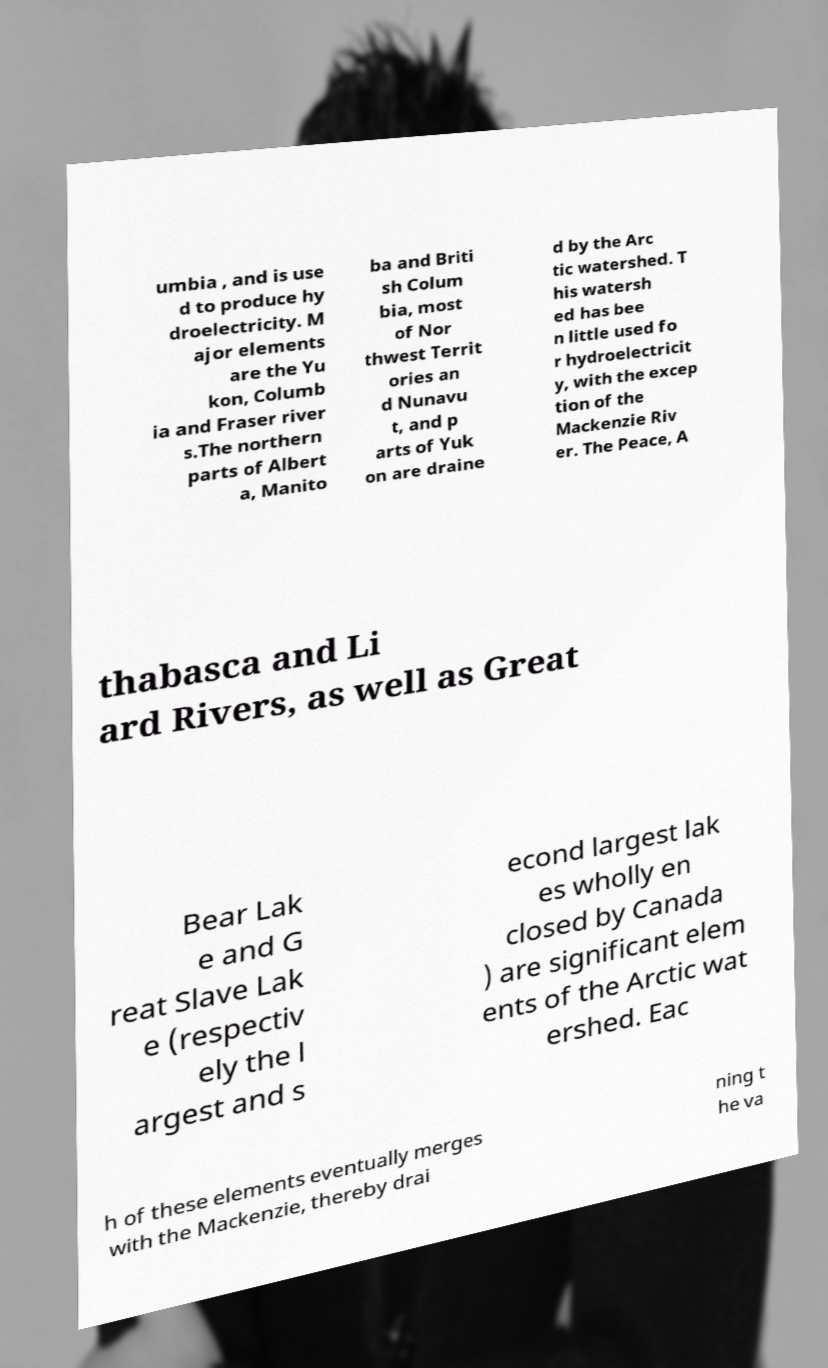Please read and relay the text visible in this image. What does it say? umbia , and is use d to produce hy droelectricity. M ajor elements are the Yu kon, Columb ia and Fraser river s.The northern parts of Albert a, Manito ba and Briti sh Colum bia, most of Nor thwest Territ ories an d Nunavu t, and p arts of Yuk on are draine d by the Arc tic watershed. T his watersh ed has bee n little used fo r hydroelectricit y, with the excep tion of the Mackenzie Riv er. The Peace, A thabasca and Li ard Rivers, as well as Great Bear Lak e and G reat Slave Lak e (respectiv ely the l argest and s econd largest lak es wholly en closed by Canada ) are significant elem ents of the Arctic wat ershed. Eac h of these elements eventually merges with the Mackenzie, thereby drai ning t he va 